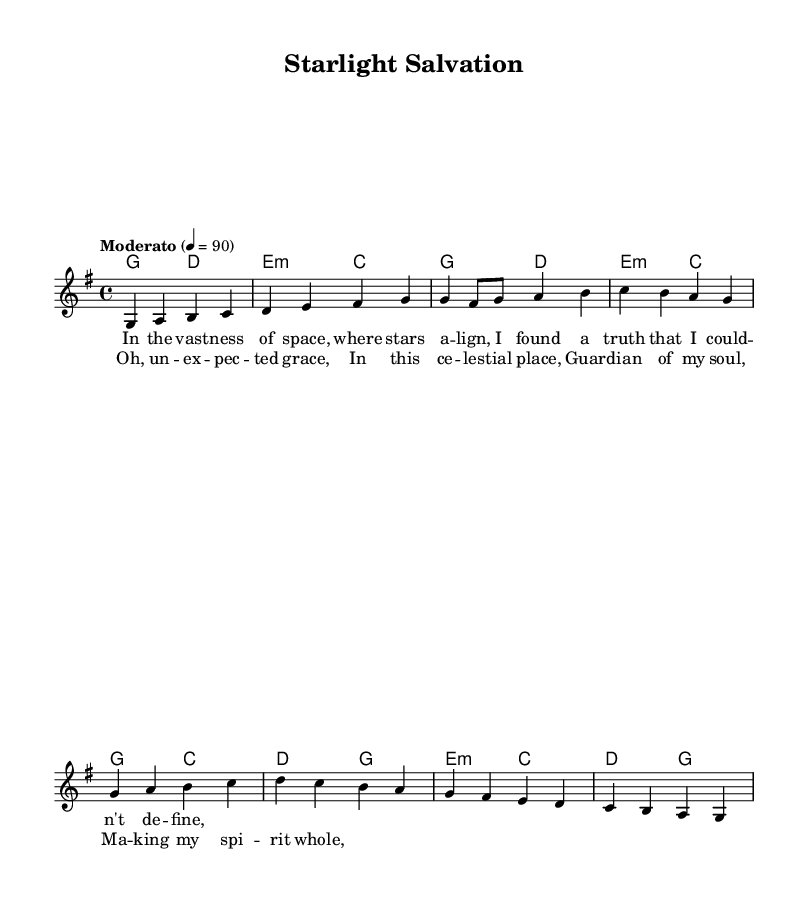What is the key signature of this music? The key signature is indicated in the global section of the code with "\key g \major", which means the piece is in the key of G major, characterized by one sharp (F#).
Answer: G major What is the time signature of the composition? The time signature is found in the global section as "\time 4/4", indicating that there are four beats in each measure and the quarter note gets one beat.
Answer: 4/4 What is the tempo marking for this piece? The tempo marking is given in the code as "\tempo "Moderato" 4 = 90", which describes the speed of the music as moderate, with a tempo of 90 beats per minute.
Answer: Moderato, 90 How many measures are in the intro section? The intro section consists of two measures, as indicated by the two lines of music that are specified for the intro in the melody section.
Answer: 2 measures What emotions are expressed in the lyrics of the chorus? The lyrics of the chorus describe feelings of grace, celestial wonder, and spiritual fulfillment; this is based on the content of the lines which highlight unexpected grace and the guardian of the soul.
Answer: Grace, celestial, spiritual What type of chords are used in the chorus? The chords used in the chorus are based on the harmonic structure present in the chord mode, which includes a mix of major and minor chords that establish a rich and uplifting sound, indicative of religious folk hymns.
Answer: Major and minor chords In what context are the unexpected places mentioned? The unexpected places refer to the celestial realm described in the song, which is a common theme in folk hymns that speaks to finding faith in surprising or untraditional places, as indicated by the lyrics in the verse and chorus.
Answer: Celestial realm 